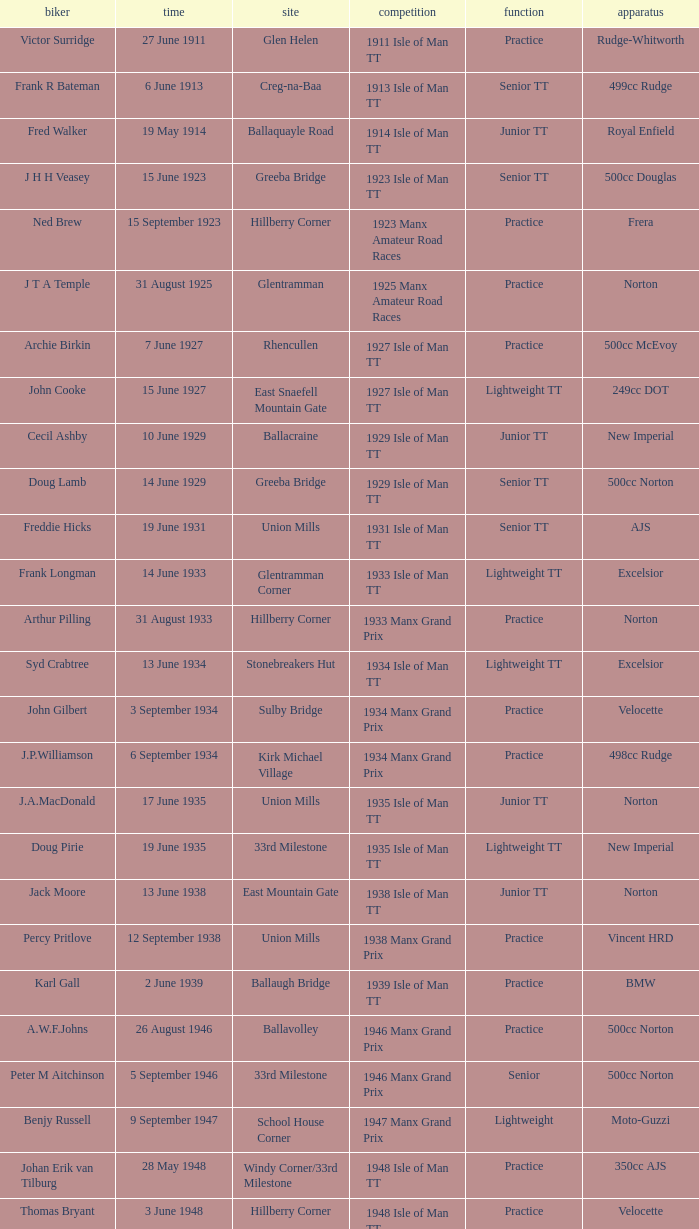Harry l Stephen rides a Norton machine on what date? 8 June 1953. 